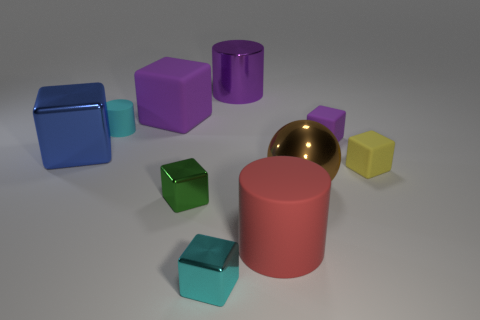Subtract 2 cubes. How many cubes are left? 4 Subtract all purple blocks. How many blocks are left? 4 Subtract all large rubber cubes. How many cubes are left? 5 Subtract all yellow blocks. Subtract all red spheres. How many blocks are left? 5 Subtract all balls. How many objects are left? 9 Add 5 big blue objects. How many big blue objects exist? 6 Subtract 1 cyan cylinders. How many objects are left? 9 Subtract all large purple blocks. Subtract all brown spheres. How many objects are left? 8 Add 2 small purple rubber cubes. How many small purple rubber cubes are left? 3 